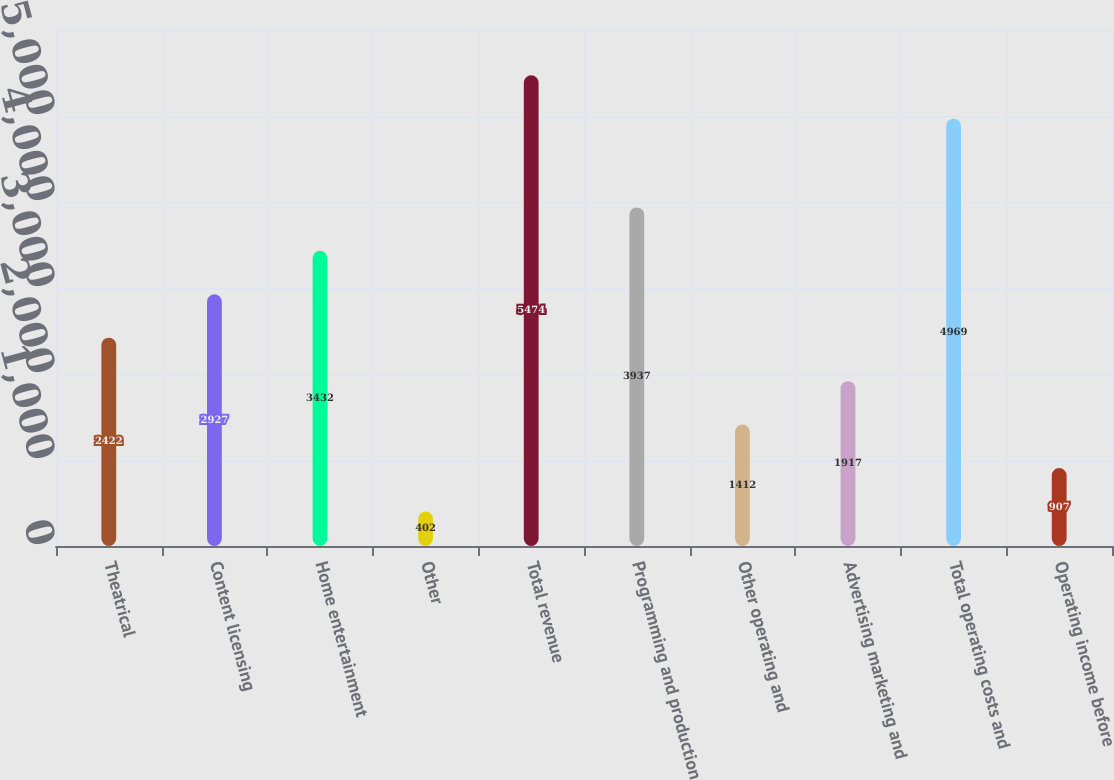Convert chart. <chart><loc_0><loc_0><loc_500><loc_500><bar_chart><fcel>Theatrical<fcel>Content licensing<fcel>Home entertainment<fcel>Other<fcel>Total revenue<fcel>Programming and production<fcel>Other operating and<fcel>Advertising marketing and<fcel>Total operating costs and<fcel>Operating income before<nl><fcel>2422<fcel>2927<fcel>3432<fcel>402<fcel>5474<fcel>3937<fcel>1412<fcel>1917<fcel>4969<fcel>907<nl></chart> 